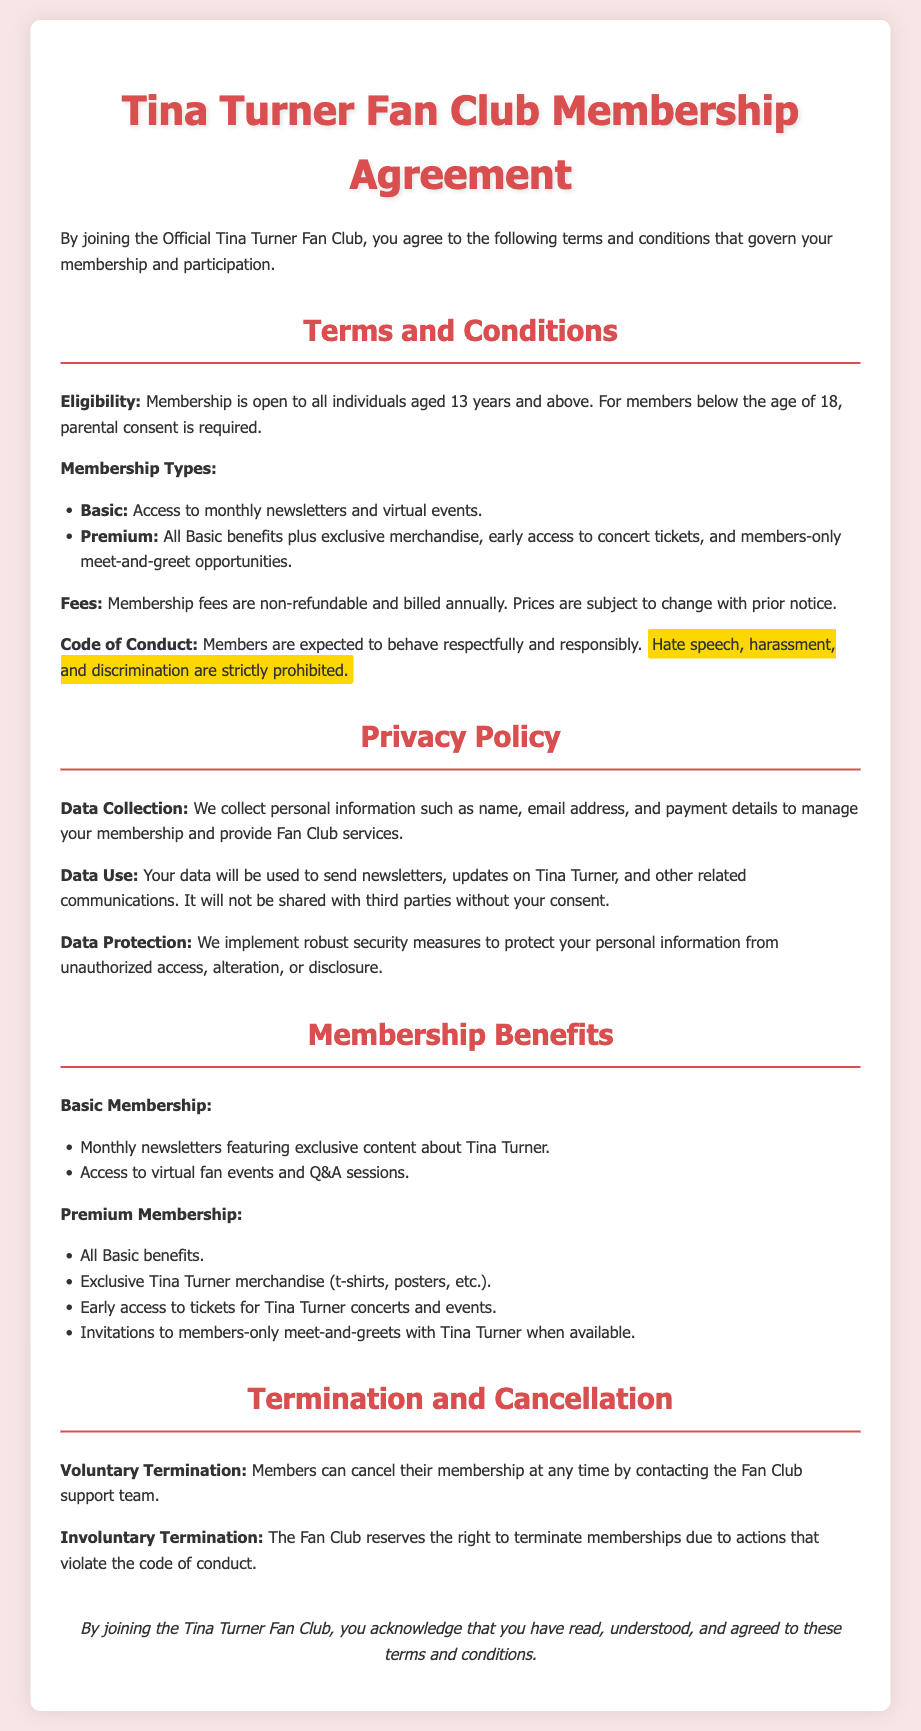What is the minimum age for membership? The eligibility section states that membership is open to individuals aged 13 years and above.
Answer: 13 years What are the two types of membership offered? The document lists the membership types as Basic and Premium.
Answer: Basic and Premium What benefits are exclusive to Premium membership? The document specifies that Premium members receive exclusive merchandise, early access to concert tickets, and meet-and-greet opportunities.
Answer: Exclusive merchandise, early access to concert tickets, and meet-and-greet opportunities Is membership fee refundable? The terms indicate that membership fees are non-refundable.
Answer: Non-refundable What is required for members under the age of 18? The eligibility section mentions that parental consent is required for members below the age of 18.
Answer: Parental consent What is the data protection measure mentioned? The document claims to implement robust security measures to protect personal information.
Answer: Robust security measures What can members do to voluntarily terminate their membership? The document states that members can cancel their membership by contacting the Fan Club support team.
Answer: Contact the Fan Club support team What actions can lead to involuntary termination of membership? The document indicates that memberships may be terminated due to actions that violate the code of conduct.
Answer: Violating the code of conduct 